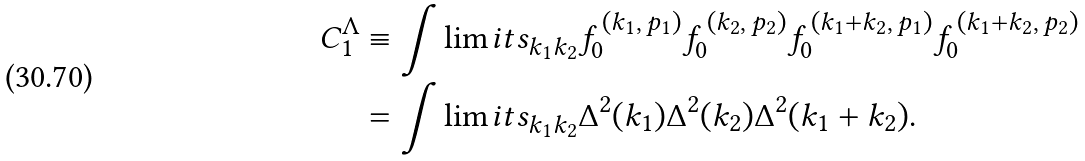Convert formula to latex. <formula><loc_0><loc_0><loc_500><loc_500>C _ { 1 } ^ { \Lambda } & \equiv \int \lim i t s _ { k _ { 1 } k _ { 2 } } f _ { 0 } ^ { \, ( k _ { 1 } , \, p _ { 1 } ) } f _ { 0 } ^ { \, ( k _ { 2 } , \, p _ { 2 } ) } f _ { 0 } ^ { \, ( k _ { 1 } + k _ { 2 } , \, p _ { 1 } ) } f _ { 0 } ^ { \, ( k _ { 1 } + k _ { 2 } , \, p _ { 2 } ) } \\ & = \int \lim i t s _ { k _ { 1 } k _ { 2 } } \Delta ^ { 2 } ( k _ { 1 } ) \Delta ^ { 2 } ( k _ { 2 } ) \Delta ^ { 2 } ( k _ { 1 } + k _ { 2 } ) .</formula> 